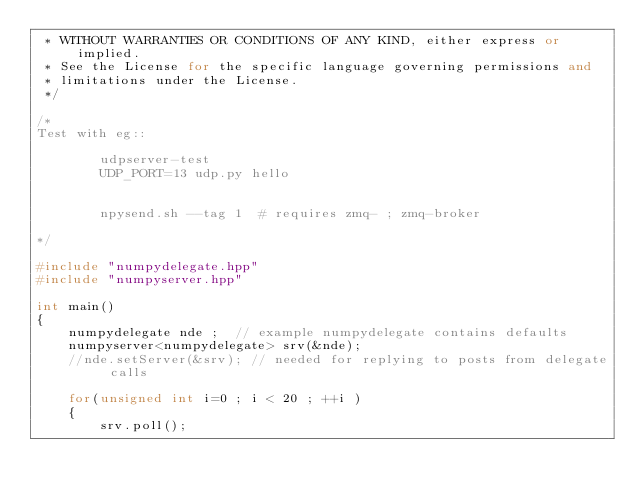<code> <loc_0><loc_0><loc_500><loc_500><_C++_> * WITHOUT WARRANTIES OR CONDITIONS OF ANY KIND, either express or implied.  
 * See the License for the specific language governing permissions and 
 * limitations under the License.
 */

/*
Test with eg::

        udpserver-test 
        UDP_PORT=13 udp.py hello


        npysend.sh --tag 1  # requires zmq- ; zmq-broker 

*/

#include "numpydelegate.hpp"
#include "numpyserver.hpp"

int main()
{
    numpydelegate nde ;  // example numpydelegate contains defaults 
    numpyserver<numpydelegate> srv(&nde);
    //nde.setServer(&srv); // needed for replying to posts from delegate calls
    
    for(unsigned int i=0 ; i < 20 ; ++i )
    {
        srv.poll();</code> 